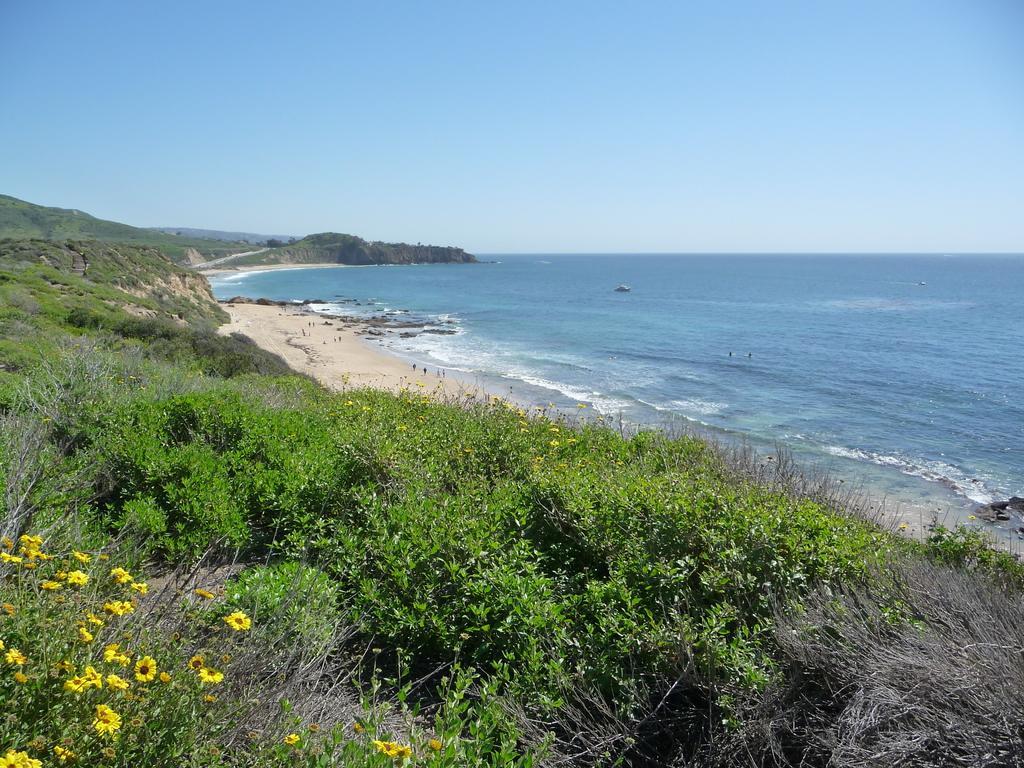Could you give a brief overview of what you see in this image? In this image I can see the yellow color flowers to the plants. To the side I can see the dried grass. In the background I can see the water and the sky in blue color. 